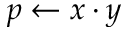Convert formula to latex. <formula><loc_0><loc_0><loc_500><loc_500>p \gets x \cdot y</formula> 